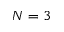<formula> <loc_0><loc_0><loc_500><loc_500>N = 3</formula> 